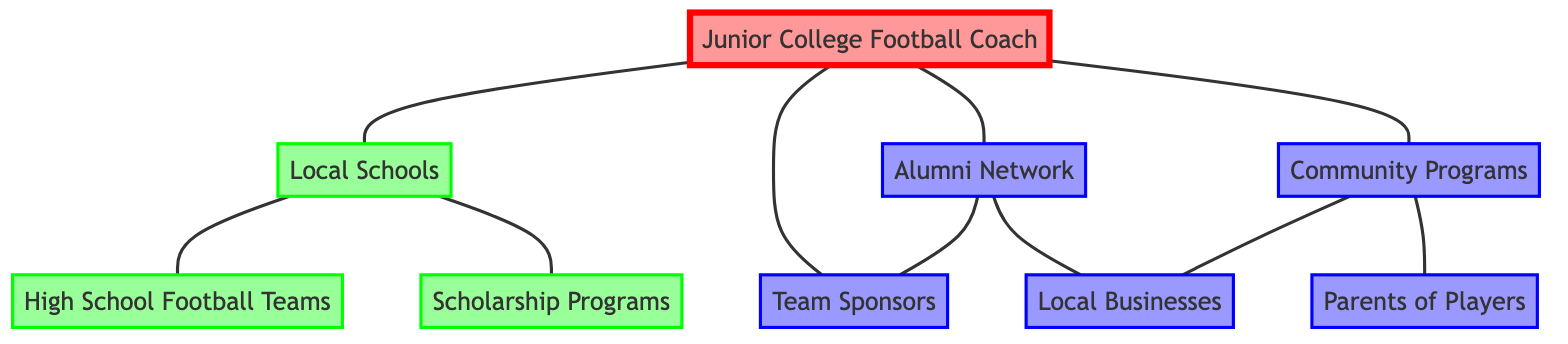What are the nodes connected to the Junior College Football Coach? The Junior College Football Coach is directly connected to Local Schools, Alumni, Sponsors, and Community Programs as indicated by the edges leading from the Coach node to these nodes.
Answer: Local Schools, Alumni, Sponsors, Community Programs How many entities are represented as nodes in the diagram? By counting the distinct entities represented as nodes, we find a total of 9 nodes including the Junior College Football Coach and the other connections.
Answer: 9 What type of programs do Local Schools connect with? Local Schools connect with High School Football Teams and Scholarship Programs, as shown by the edges that branch out from Local Schools down to these two nodes.
Answer: High School Football Teams, Scholarship Programs Who connects Alumni to Local Businesses? The Alumni Network connects to Local Businesses through an edge that indicates a direct relationship, showing that the Alumni are engaged with these businesses.
Answer: Alumni Which node has the most connections in the diagram? The Junior College Football Coach has four direct connections, more than any other node in the diagram, showing their central role in the community engagement network.
Answer: Junior College Football Coach What community involvement do Community Programs have? Community Programs are involved with Local Businesses and Parents of Players, suggesting their role in linking these two groups through the edges connecting them.
Answer: Local Businesses, Parents Is there any relationship between Alumni and Sponsors? Yes, there is a direct edge between Alumni and Sponsors, which illustrates that these two nodes are connected and likely collaborate or interact in some capacity.
Answer: Yes What role do Parents play in relation to Community Programs? Parents are connected to Community Programs directly, indicating that they are likely participants or beneficiaries of these programs organized for community engagement.
Answer: Participants Do Local Schools interact with both Alumni and Coaches? Yes, both the Junior College Football Coach and Alumni Network have direct connections to Local Schools, indicating their collaborative efforts in engaging with schools.
Answer: Yes 